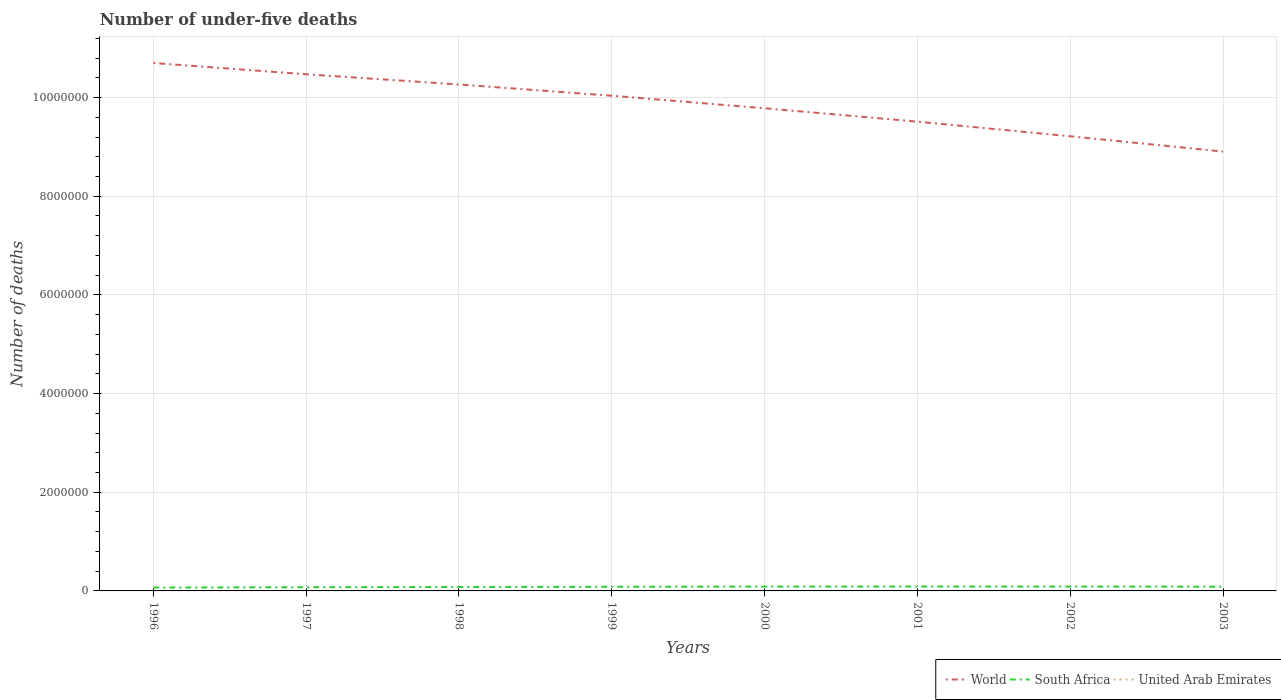Across all years, what is the maximum number of under-five deaths in South Africa?
Offer a terse response. 6.91e+04. In which year was the number of under-five deaths in United Arab Emirates maximum?
Keep it short and to the point. 2003. What is the total number of under-five deaths in South Africa in the graph?
Your answer should be compact. -2.02e+04. What is the difference between the highest and the second highest number of under-five deaths in World?
Keep it short and to the point. 1.80e+06. What is the difference between the highest and the lowest number of under-five deaths in United Arab Emirates?
Provide a succinct answer. 5. Is the number of under-five deaths in World strictly greater than the number of under-five deaths in South Africa over the years?
Offer a terse response. No. How many years are there in the graph?
Offer a terse response. 8. What is the difference between two consecutive major ticks on the Y-axis?
Provide a succinct answer. 2.00e+06. Where does the legend appear in the graph?
Offer a terse response. Bottom right. What is the title of the graph?
Provide a succinct answer. Number of under-five deaths. What is the label or title of the X-axis?
Your response must be concise. Years. What is the label or title of the Y-axis?
Offer a very short reply. Number of deaths. What is the Number of deaths of World in 1996?
Your answer should be compact. 1.07e+07. What is the Number of deaths in South Africa in 1996?
Make the answer very short. 6.91e+04. What is the Number of deaths in United Arab Emirates in 1996?
Provide a succinct answer. 561. What is the Number of deaths in World in 1997?
Provide a succinct answer. 1.05e+07. What is the Number of deaths in South Africa in 1997?
Your answer should be very brief. 7.42e+04. What is the Number of deaths of United Arab Emirates in 1997?
Your answer should be very brief. 557. What is the Number of deaths of World in 1998?
Your response must be concise. 1.03e+07. What is the Number of deaths in South Africa in 1998?
Ensure brevity in your answer.  7.96e+04. What is the Number of deaths of United Arab Emirates in 1998?
Give a very brief answer. 557. What is the Number of deaths in World in 1999?
Offer a terse response. 1.00e+07. What is the Number of deaths of South Africa in 1999?
Provide a succinct answer. 8.43e+04. What is the Number of deaths in United Arab Emirates in 1999?
Offer a very short reply. 563. What is the Number of deaths of World in 2000?
Your answer should be compact. 9.78e+06. What is the Number of deaths in South Africa in 2000?
Your response must be concise. 8.79e+04. What is the Number of deaths of United Arab Emirates in 2000?
Offer a very short reply. 563. What is the Number of deaths in World in 2001?
Your answer should be very brief. 9.51e+06. What is the Number of deaths of South Africa in 2001?
Your response must be concise. 8.93e+04. What is the Number of deaths in United Arab Emirates in 2001?
Provide a short and direct response. 544. What is the Number of deaths of World in 2002?
Your response must be concise. 9.21e+06. What is the Number of deaths of South Africa in 2002?
Provide a succinct answer. 8.84e+04. What is the Number of deaths of United Arab Emirates in 2002?
Ensure brevity in your answer.  523. What is the Number of deaths in World in 2003?
Your response must be concise. 8.91e+06. What is the Number of deaths in South Africa in 2003?
Your response must be concise. 8.58e+04. What is the Number of deaths in United Arab Emirates in 2003?
Your answer should be compact. 514. Across all years, what is the maximum Number of deaths of World?
Offer a terse response. 1.07e+07. Across all years, what is the maximum Number of deaths of South Africa?
Your response must be concise. 8.93e+04. Across all years, what is the maximum Number of deaths of United Arab Emirates?
Make the answer very short. 563. Across all years, what is the minimum Number of deaths of World?
Offer a very short reply. 8.91e+06. Across all years, what is the minimum Number of deaths in South Africa?
Offer a terse response. 6.91e+04. Across all years, what is the minimum Number of deaths in United Arab Emirates?
Ensure brevity in your answer.  514. What is the total Number of deaths in World in the graph?
Provide a succinct answer. 7.89e+07. What is the total Number of deaths in South Africa in the graph?
Your response must be concise. 6.59e+05. What is the total Number of deaths in United Arab Emirates in the graph?
Your answer should be very brief. 4382. What is the difference between the Number of deaths in World in 1996 and that in 1997?
Give a very brief answer. 2.29e+05. What is the difference between the Number of deaths of South Africa in 1996 and that in 1997?
Keep it short and to the point. -5126. What is the difference between the Number of deaths of World in 1996 and that in 1998?
Your answer should be very brief. 4.36e+05. What is the difference between the Number of deaths in South Africa in 1996 and that in 1998?
Offer a terse response. -1.05e+04. What is the difference between the Number of deaths in United Arab Emirates in 1996 and that in 1998?
Make the answer very short. 4. What is the difference between the Number of deaths of World in 1996 and that in 1999?
Ensure brevity in your answer.  6.64e+05. What is the difference between the Number of deaths of South Africa in 1996 and that in 1999?
Ensure brevity in your answer.  -1.52e+04. What is the difference between the Number of deaths of United Arab Emirates in 1996 and that in 1999?
Ensure brevity in your answer.  -2. What is the difference between the Number of deaths in World in 1996 and that in 2000?
Offer a very short reply. 9.18e+05. What is the difference between the Number of deaths of South Africa in 1996 and that in 2000?
Your answer should be very brief. -1.88e+04. What is the difference between the Number of deaths in World in 1996 and that in 2001?
Provide a short and direct response. 1.19e+06. What is the difference between the Number of deaths in South Africa in 1996 and that in 2001?
Provide a short and direct response. -2.02e+04. What is the difference between the Number of deaths of World in 1996 and that in 2002?
Your response must be concise. 1.49e+06. What is the difference between the Number of deaths in South Africa in 1996 and that in 2002?
Make the answer very short. -1.93e+04. What is the difference between the Number of deaths of United Arab Emirates in 1996 and that in 2002?
Your answer should be very brief. 38. What is the difference between the Number of deaths in World in 1996 and that in 2003?
Your response must be concise. 1.80e+06. What is the difference between the Number of deaths of South Africa in 1996 and that in 2003?
Your response must be concise. -1.67e+04. What is the difference between the Number of deaths in United Arab Emirates in 1996 and that in 2003?
Your answer should be very brief. 47. What is the difference between the Number of deaths of World in 1997 and that in 1998?
Offer a terse response. 2.07e+05. What is the difference between the Number of deaths of South Africa in 1997 and that in 1998?
Make the answer very short. -5402. What is the difference between the Number of deaths in United Arab Emirates in 1997 and that in 1998?
Your answer should be very brief. 0. What is the difference between the Number of deaths of World in 1997 and that in 1999?
Your answer should be very brief. 4.35e+05. What is the difference between the Number of deaths of South Africa in 1997 and that in 1999?
Provide a short and direct response. -1.01e+04. What is the difference between the Number of deaths of World in 1997 and that in 2000?
Your answer should be compact. 6.89e+05. What is the difference between the Number of deaths of South Africa in 1997 and that in 2000?
Your response must be concise. -1.37e+04. What is the difference between the Number of deaths in World in 1997 and that in 2001?
Your answer should be compact. 9.60e+05. What is the difference between the Number of deaths in South Africa in 1997 and that in 2001?
Keep it short and to the point. -1.51e+04. What is the difference between the Number of deaths in World in 1997 and that in 2002?
Offer a terse response. 1.26e+06. What is the difference between the Number of deaths of South Africa in 1997 and that in 2002?
Offer a terse response. -1.42e+04. What is the difference between the Number of deaths of World in 1997 and that in 2003?
Offer a terse response. 1.57e+06. What is the difference between the Number of deaths in South Africa in 1997 and that in 2003?
Offer a very short reply. -1.15e+04. What is the difference between the Number of deaths of World in 1998 and that in 1999?
Your answer should be compact. 2.28e+05. What is the difference between the Number of deaths in South Africa in 1998 and that in 1999?
Provide a short and direct response. -4712. What is the difference between the Number of deaths in United Arab Emirates in 1998 and that in 1999?
Offer a terse response. -6. What is the difference between the Number of deaths of World in 1998 and that in 2000?
Ensure brevity in your answer.  4.82e+05. What is the difference between the Number of deaths in South Africa in 1998 and that in 2000?
Your answer should be very brief. -8266. What is the difference between the Number of deaths in World in 1998 and that in 2001?
Provide a short and direct response. 7.53e+05. What is the difference between the Number of deaths in South Africa in 1998 and that in 2001?
Give a very brief answer. -9711. What is the difference between the Number of deaths of World in 1998 and that in 2002?
Offer a very short reply. 1.05e+06. What is the difference between the Number of deaths of South Africa in 1998 and that in 2002?
Offer a very short reply. -8818. What is the difference between the Number of deaths in World in 1998 and that in 2003?
Offer a very short reply. 1.36e+06. What is the difference between the Number of deaths of South Africa in 1998 and that in 2003?
Your answer should be very brief. -6147. What is the difference between the Number of deaths in United Arab Emirates in 1998 and that in 2003?
Make the answer very short. 43. What is the difference between the Number of deaths of World in 1999 and that in 2000?
Keep it short and to the point. 2.54e+05. What is the difference between the Number of deaths in South Africa in 1999 and that in 2000?
Keep it short and to the point. -3554. What is the difference between the Number of deaths in World in 1999 and that in 2001?
Offer a very short reply. 5.25e+05. What is the difference between the Number of deaths in South Africa in 1999 and that in 2001?
Provide a succinct answer. -4999. What is the difference between the Number of deaths in United Arab Emirates in 1999 and that in 2001?
Your response must be concise. 19. What is the difference between the Number of deaths in World in 1999 and that in 2002?
Your answer should be compact. 8.22e+05. What is the difference between the Number of deaths in South Africa in 1999 and that in 2002?
Your response must be concise. -4106. What is the difference between the Number of deaths in World in 1999 and that in 2003?
Your answer should be very brief. 1.13e+06. What is the difference between the Number of deaths of South Africa in 1999 and that in 2003?
Offer a very short reply. -1435. What is the difference between the Number of deaths in World in 2000 and that in 2001?
Your answer should be compact. 2.71e+05. What is the difference between the Number of deaths of South Africa in 2000 and that in 2001?
Provide a short and direct response. -1445. What is the difference between the Number of deaths in World in 2000 and that in 2002?
Give a very brief answer. 5.68e+05. What is the difference between the Number of deaths of South Africa in 2000 and that in 2002?
Give a very brief answer. -552. What is the difference between the Number of deaths of United Arab Emirates in 2000 and that in 2002?
Provide a succinct answer. 40. What is the difference between the Number of deaths in World in 2000 and that in 2003?
Give a very brief answer. 8.78e+05. What is the difference between the Number of deaths in South Africa in 2000 and that in 2003?
Your answer should be very brief. 2119. What is the difference between the Number of deaths of United Arab Emirates in 2000 and that in 2003?
Your answer should be compact. 49. What is the difference between the Number of deaths of World in 2001 and that in 2002?
Offer a terse response. 2.97e+05. What is the difference between the Number of deaths in South Africa in 2001 and that in 2002?
Offer a very short reply. 893. What is the difference between the Number of deaths of World in 2001 and that in 2003?
Offer a terse response. 6.07e+05. What is the difference between the Number of deaths in South Africa in 2001 and that in 2003?
Provide a short and direct response. 3564. What is the difference between the Number of deaths of United Arab Emirates in 2001 and that in 2003?
Your answer should be very brief. 30. What is the difference between the Number of deaths in World in 2002 and that in 2003?
Offer a very short reply. 3.10e+05. What is the difference between the Number of deaths in South Africa in 2002 and that in 2003?
Make the answer very short. 2671. What is the difference between the Number of deaths in World in 1996 and the Number of deaths in South Africa in 1997?
Provide a short and direct response. 1.06e+07. What is the difference between the Number of deaths of World in 1996 and the Number of deaths of United Arab Emirates in 1997?
Provide a succinct answer. 1.07e+07. What is the difference between the Number of deaths of South Africa in 1996 and the Number of deaths of United Arab Emirates in 1997?
Your answer should be compact. 6.85e+04. What is the difference between the Number of deaths in World in 1996 and the Number of deaths in South Africa in 1998?
Offer a very short reply. 1.06e+07. What is the difference between the Number of deaths in World in 1996 and the Number of deaths in United Arab Emirates in 1998?
Provide a succinct answer. 1.07e+07. What is the difference between the Number of deaths of South Africa in 1996 and the Number of deaths of United Arab Emirates in 1998?
Keep it short and to the point. 6.85e+04. What is the difference between the Number of deaths in World in 1996 and the Number of deaths in South Africa in 1999?
Give a very brief answer. 1.06e+07. What is the difference between the Number of deaths in World in 1996 and the Number of deaths in United Arab Emirates in 1999?
Your response must be concise. 1.07e+07. What is the difference between the Number of deaths in South Africa in 1996 and the Number of deaths in United Arab Emirates in 1999?
Your answer should be very brief. 6.85e+04. What is the difference between the Number of deaths in World in 1996 and the Number of deaths in South Africa in 2000?
Offer a very short reply. 1.06e+07. What is the difference between the Number of deaths of World in 1996 and the Number of deaths of United Arab Emirates in 2000?
Give a very brief answer. 1.07e+07. What is the difference between the Number of deaths in South Africa in 1996 and the Number of deaths in United Arab Emirates in 2000?
Ensure brevity in your answer.  6.85e+04. What is the difference between the Number of deaths in World in 1996 and the Number of deaths in South Africa in 2001?
Keep it short and to the point. 1.06e+07. What is the difference between the Number of deaths in World in 1996 and the Number of deaths in United Arab Emirates in 2001?
Keep it short and to the point. 1.07e+07. What is the difference between the Number of deaths in South Africa in 1996 and the Number of deaths in United Arab Emirates in 2001?
Offer a very short reply. 6.85e+04. What is the difference between the Number of deaths of World in 1996 and the Number of deaths of South Africa in 2002?
Make the answer very short. 1.06e+07. What is the difference between the Number of deaths in World in 1996 and the Number of deaths in United Arab Emirates in 2002?
Your response must be concise. 1.07e+07. What is the difference between the Number of deaths in South Africa in 1996 and the Number of deaths in United Arab Emirates in 2002?
Make the answer very short. 6.86e+04. What is the difference between the Number of deaths in World in 1996 and the Number of deaths in South Africa in 2003?
Provide a short and direct response. 1.06e+07. What is the difference between the Number of deaths of World in 1996 and the Number of deaths of United Arab Emirates in 2003?
Provide a short and direct response. 1.07e+07. What is the difference between the Number of deaths in South Africa in 1996 and the Number of deaths in United Arab Emirates in 2003?
Your answer should be compact. 6.86e+04. What is the difference between the Number of deaths in World in 1997 and the Number of deaths in South Africa in 1998?
Your answer should be very brief. 1.04e+07. What is the difference between the Number of deaths of World in 1997 and the Number of deaths of United Arab Emirates in 1998?
Offer a very short reply. 1.05e+07. What is the difference between the Number of deaths in South Africa in 1997 and the Number of deaths in United Arab Emirates in 1998?
Offer a very short reply. 7.37e+04. What is the difference between the Number of deaths in World in 1997 and the Number of deaths in South Africa in 1999?
Provide a short and direct response. 1.04e+07. What is the difference between the Number of deaths of World in 1997 and the Number of deaths of United Arab Emirates in 1999?
Make the answer very short. 1.05e+07. What is the difference between the Number of deaths in South Africa in 1997 and the Number of deaths in United Arab Emirates in 1999?
Your answer should be compact. 7.36e+04. What is the difference between the Number of deaths in World in 1997 and the Number of deaths in South Africa in 2000?
Give a very brief answer. 1.04e+07. What is the difference between the Number of deaths in World in 1997 and the Number of deaths in United Arab Emirates in 2000?
Your answer should be very brief. 1.05e+07. What is the difference between the Number of deaths of South Africa in 1997 and the Number of deaths of United Arab Emirates in 2000?
Your answer should be very brief. 7.36e+04. What is the difference between the Number of deaths in World in 1997 and the Number of deaths in South Africa in 2001?
Make the answer very short. 1.04e+07. What is the difference between the Number of deaths of World in 1997 and the Number of deaths of United Arab Emirates in 2001?
Keep it short and to the point. 1.05e+07. What is the difference between the Number of deaths of South Africa in 1997 and the Number of deaths of United Arab Emirates in 2001?
Your answer should be compact. 7.37e+04. What is the difference between the Number of deaths of World in 1997 and the Number of deaths of South Africa in 2002?
Ensure brevity in your answer.  1.04e+07. What is the difference between the Number of deaths of World in 1997 and the Number of deaths of United Arab Emirates in 2002?
Make the answer very short. 1.05e+07. What is the difference between the Number of deaths in South Africa in 1997 and the Number of deaths in United Arab Emirates in 2002?
Your answer should be compact. 7.37e+04. What is the difference between the Number of deaths in World in 1997 and the Number of deaths in South Africa in 2003?
Make the answer very short. 1.04e+07. What is the difference between the Number of deaths of World in 1997 and the Number of deaths of United Arab Emirates in 2003?
Give a very brief answer. 1.05e+07. What is the difference between the Number of deaths of South Africa in 1997 and the Number of deaths of United Arab Emirates in 2003?
Make the answer very short. 7.37e+04. What is the difference between the Number of deaths of World in 1998 and the Number of deaths of South Africa in 1999?
Make the answer very short. 1.02e+07. What is the difference between the Number of deaths in World in 1998 and the Number of deaths in United Arab Emirates in 1999?
Give a very brief answer. 1.03e+07. What is the difference between the Number of deaths of South Africa in 1998 and the Number of deaths of United Arab Emirates in 1999?
Provide a short and direct response. 7.90e+04. What is the difference between the Number of deaths in World in 1998 and the Number of deaths in South Africa in 2000?
Provide a succinct answer. 1.02e+07. What is the difference between the Number of deaths in World in 1998 and the Number of deaths in United Arab Emirates in 2000?
Provide a succinct answer. 1.03e+07. What is the difference between the Number of deaths in South Africa in 1998 and the Number of deaths in United Arab Emirates in 2000?
Provide a short and direct response. 7.90e+04. What is the difference between the Number of deaths of World in 1998 and the Number of deaths of South Africa in 2001?
Give a very brief answer. 1.02e+07. What is the difference between the Number of deaths in World in 1998 and the Number of deaths in United Arab Emirates in 2001?
Your answer should be very brief. 1.03e+07. What is the difference between the Number of deaths in South Africa in 1998 and the Number of deaths in United Arab Emirates in 2001?
Your response must be concise. 7.91e+04. What is the difference between the Number of deaths of World in 1998 and the Number of deaths of South Africa in 2002?
Offer a terse response. 1.02e+07. What is the difference between the Number of deaths in World in 1998 and the Number of deaths in United Arab Emirates in 2002?
Offer a terse response. 1.03e+07. What is the difference between the Number of deaths of South Africa in 1998 and the Number of deaths of United Arab Emirates in 2002?
Ensure brevity in your answer.  7.91e+04. What is the difference between the Number of deaths of World in 1998 and the Number of deaths of South Africa in 2003?
Offer a very short reply. 1.02e+07. What is the difference between the Number of deaths of World in 1998 and the Number of deaths of United Arab Emirates in 2003?
Offer a terse response. 1.03e+07. What is the difference between the Number of deaths of South Africa in 1998 and the Number of deaths of United Arab Emirates in 2003?
Make the answer very short. 7.91e+04. What is the difference between the Number of deaths in World in 1999 and the Number of deaths in South Africa in 2000?
Keep it short and to the point. 9.95e+06. What is the difference between the Number of deaths in World in 1999 and the Number of deaths in United Arab Emirates in 2000?
Offer a terse response. 1.00e+07. What is the difference between the Number of deaths of South Africa in 1999 and the Number of deaths of United Arab Emirates in 2000?
Make the answer very short. 8.38e+04. What is the difference between the Number of deaths in World in 1999 and the Number of deaths in South Africa in 2001?
Provide a succinct answer. 9.95e+06. What is the difference between the Number of deaths of World in 1999 and the Number of deaths of United Arab Emirates in 2001?
Your answer should be compact. 1.00e+07. What is the difference between the Number of deaths in South Africa in 1999 and the Number of deaths in United Arab Emirates in 2001?
Offer a terse response. 8.38e+04. What is the difference between the Number of deaths of World in 1999 and the Number of deaths of South Africa in 2002?
Offer a very short reply. 9.95e+06. What is the difference between the Number of deaths in World in 1999 and the Number of deaths in United Arab Emirates in 2002?
Offer a terse response. 1.00e+07. What is the difference between the Number of deaths in South Africa in 1999 and the Number of deaths in United Arab Emirates in 2002?
Your answer should be compact. 8.38e+04. What is the difference between the Number of deaths of World in 1999 and the Number of deaths of South Africa in 2003?
Your answer should be compact. 9.95e+06. What is the difference between the Number of deaths in World in 1999 and the Number of deaths in United Arab Emirates in 2003?
Give a very brief answer. 1.00e+07. What is the difference between the Number of deaths in South Africa in 1999 and the Number of deaths in United Arab Emirates in 2003?
Your response must be concise. 8.38e+04. What is the difference between the Number of deaths of World in 2000 and the Number of deaths of South Africa in 2001?
Provide a succinct answer. 9.69e+06. What is the difference between the Number of deaths in World in 2000 and the Number of deaths in United Arab Emirates in 2001?
Provide a short and direct response. 9.78e+06. What is the difference between the Number of deaths in South Africa in 2000 and the Number of deaths in United Arab Emirates in 2001?
Provide a short and direct response. 8.73e+04. What is the difference between the Number of deaths of World in 2000 and the Number of deaths of South Africa in 2002?
Your response must be concise. 9.69e+06. What is the difference between the Number of deaths in World in 2000 and the Number of deaths in United Arab Emirates in 2002?
Provide a short and direct response. 9.78e+06. What is the difference between the Number of deaths in South Africa in 2000 and the Number of deaths in United Arab Emirates in 2002?
Ensure brevity in your answer.  8.74e+04. What is the difference between the Number of deaths in World in 2000 and the Number of deaths in South Africa in 2003?
Your response must be concise. 9.70e+06. What is the difference between the Number of deaths of World in 2000 and the Number of deaths of United Arab Emirates in 2003?
Offer a terse response. 9.78e+06. What is the difference between the Number of deaths in South Africa in 2000 and the Number of deaths in United Arab Emirates in 2003?
Your response must be concise. 8.74e+04. What is the difference between the Number of deaths of World in 2001 and the Number of deaths of South Africa in 2002?
Ensure brevity in your answer.  9.42e+06. What is the difference between the Number of deaths of World in 2001 and the Number of deaths of United Arab Emirates in 2002?
Make the answer very short. 9.51e+06. What is the difference between the Number of deaths in South Africa in 2001 and the Number of deaths in United Arab Emirates in 2002?
Provide a short and direct response. 8.88e+04. What is the difference between the Number of deaths in World in 2001 and the Number of deaths in South Africa in 2003?
Offer a very short reply. 9.43e+06. What is the difference between the Number of deaths in World in 2001 and the Number of deaths in United Arab Emirates in 2003?
Ensure brevity in your answer.  9.51e+06. What is the difference between the Number of deaths of South Africa in 2001 and the Number of deaths of United Arab Emirates in 2003?
Provide a succinct answer. 8.88e+04. What is the difference between the Number of deaths in World in 2002 and the Number of deaths in South Africa in 2003?
Your answer should be very brief. 9.13e+06. What is the difference between the Number of deaths in World in 2002 and the Number of deaths in United Arab Emirates in 2003?
Keep it short and to the point. 9.21e+06. What is the difference between the Number of deaths in South Africa in 2002 and the Number of deaths in United Arab Emirates in 2003?
Keep it short and to the point. 8.79e+04. What is the average Number of deaths in World per year?
Your response must be concise. 9.86e+06. What is the average Number of deaths in South Africa per year?
Provide a succinct answer. 8.23e+04. What is the average Number of deaths of United Arab Emirates per year?
Make the answer very short. 547.75. In the year 1996, what is the difference between the Number of deaths in World and Number of deaths in South Africa?
Ensure brevity in your answer.  1.06e+07. In the year 1996, what is the difference between the Number of deaths of World and Number of deaths of United Arab Emirates?
Keep it short and to the point. 1.07e+07. In the year 1996, what is the difference between the Number of deaths in South Africa and Number of deaths in United Arab Emirates?
Offer a terse response. 6.85e+04. In the year 1997, what is the difference between the Number of deaths of World and Number of deaths of South Africa?
Your answer should be very brief. 1.04e+07. In the year 1997, what is the difference between the Number of deaths in World and Number of deaths in United Arab Emirates?
Ensure brevity in your answer.  1.05e+07. In the year 1997, what is the difference between the Number of deaths of South Africa and Number of deaths of United Arab Emirates?
Provide a succinct answer. 7.37e+04. In the year 1998, what is the difference between the Number of deaths in World and Number of deaths in South Africa?
Give a very brief answer. 1.02e+07. In the year 1998, what is the difference between the Number of deaths of World and Number of deaths of United Arab Emirates?
Provide a succinct answer. 1.03e+07. In the year 1998, what is the difference between the Number of deaths in South Africa and Number of deaths in United Arab Emirates?
Keep it short and to the point. 7.91e+04. In the year 1999, what is the difference between the Number of deaths in World and Number of deaths in South Africa?
Ensure brevity in your answer.  9.95e+06. In the year 1999, what is the difference between the Number of deaths in World and Number of deaths in United Arab Emirates?
Provide a short and direct response. 1.00e+07. In the year 1999, what is the difference between the Number of deaths of South Africa and Number of deaths of United Arab Emirates?
Provide a short and direct response. 8.38e+04. In the year 2000, what is the difference between the Number of deaths in World and Number of deaths in South Africa?
Your answer should be very brief. 9.69e+06. In the year 2000, what is the difference between the Number of deaths in World and Number of deaths in United Arab Emirates?
Your answer should be compact. 9.78e+06. In the year 2000, what is the difference between the Number of deaths of South Africa and Number of deaths of United Arab Emirates?
Offer a terse response. 8.73e+04. In the year 2001, what is the difference between the Number of deaths of World and Number of deaths of South Africa?
Provide a short and direct response. 9.42e+06. In the year 2001, what is the difference between the Number of deaths of World and Number of deaths of United Arab Emirates?
Provide a succinct answer. 9.51e+06. In the year 2001, what is the difference between the Number of deaths in South Africa and Number of deaths in United Arab Emirates?
Make the answer very short. 8.88e+04. In the year 2002, what is the difference between the Number of deaths of World and Number of deaths of South Africa?
Your answer should be very brief. 9.13e+06. In the year 2002, what is the difference between the Number of deaths in World and Number of deaths in United Arab Emirates?
Offer a terse response. 9.21e+06. In the year 2002, what is the difference between the Number of deaths in South Africa and Number of deaths in United Arab Emirates?
Keep it short and to the point. 8.79e+04. In the year 2003, what is the difference between the Number of deaths of World and Number of deaths of South Africa?
Provide a short and direct response. 8.82e+06. In the year 2003, what is the difference between the Number of deaths in World and Number of deaths in United Arab Emirates?
Provide a short and direct response. 8.90e+06. In the year 2003, what is the difference between the Number of deaths of South Africa and Number of deaths of United Arab Emirates?
Provide a short and direct response. 8.52e+04. What is the ratio of the Number of deaths of World in 1996 to that in 1997?
Give a very brief answer. 1.02. What is the ratio of the Number of deaths of South Africa in 1996 to that in 1997?
Give a very brief answer. 0.93. What is the ratio of the Number of deaths of United Arab Emirates in 1996 to that in 1997?
Your response must be concise. 1.01. What is the ratio of the Number of deaths of World in 1996 to that in 1998?
Your answer should be compact. 1.04. What is the ratio of the Number of deaths of South Africa in 1996 to that in 1998?
Provide a short and direct response. 0.87. What is the ratio of the Number of deaths of World in 1996 to that in 1999?
Keep it short and to the point. 1.07. What is the ratio of the Number of deaths of South Africa in 1996 to that in 1999?
Your response must be concise. 0.82. What is the ratio of the Number of deaths of United Arab Emirates in 1996 to that in 1999?
Offer a very short reply. 1. What is the ratio of the Number of deaths in World in 1996 to that in 2000?
Offer a very short reply. 1.09. What is the ratio of the Number of deaths in South Africa in 1996 to that in 2000?
Make the answer very short. 0.79. What is the ratio of the Number of deaths in United Arab Emirates in 1996 to that in 2000?
Your response must be concise. 1. What is the ratio of the Number of deaths of World in 1996 to that in 2001?
Your response must be concise. 1.12. What is the ratio of the Number of deaths in South Africa in 1996 to that in 2001?
Your answer should be very brief. 0.77. What is the ratio of the Number of deaths of United Arab Emirates in 1996 to that in 2001?
Provide a succinct answer. 1.03. What is the ratio of the Number of deaths in World in 1996 to that in 2002?
Offer a terse response. 1.16. What is the ratio of the Number of deaths of South Africa in 1996 to that in 2002?
Ensure brevity in your answer.  0.78. What is the ratio of the Number of deaths in United Arab Emirates in 1996 to that in 2002?
Make the answer very short. 1.07. What is the ratio of the Number of deaths in World in 1996 to that in 2003?
Offer a terse response. 1.2. What is the ratio of the Number of deaths in South Africa in 1996 to that in 2003?
Provide a succinct answer. 0.81. What is the ratio of the Number of deaths in United Arab Emirates in 1996 to that in 2003?
Your response must be concise. 1.09. What is the ratio of the Number of deaths in World in 1997 to that in 1998?
Keep it short and to the point. 1.02. What is the ratio of the Number of deaths of South Africa in 1997 to that in 1998?
Your response must be concise. 0.93. What is the ratio of the Number of deaths in United Arab Emirates in 1997 to that in 1998?
Your response must be concise. 1. What is the ratio of the Number of deaths in World in 1997 to that in 1999?
Offer a terse response. 1.04. What is the ratio of the Number of deaths in South Africa in 1997 to that in 1999?
Ensure brevity in your answer.  0.88. What is the ratio of the Number of deaths in United Arab Emirates in 1997 to that in 1999?
Offer a terse response. 0.99. What is the ratio of the Number of deaths of World in 1997 to that in 2000?
Offer a very short reply. 1.07. What is the ratio of the Number of deaths of South Africa in 1997 to that in 2000?
Make the answer very short. 0.84. What is the ratio of the Number of deaths of United Arab Emirates in 1997 to that in 2000?
Offer a very short reply. 0.99. What is the ratio of the Number of deaths in World in 1997 to that in 2001?
Offer a terse response. 1.1. What is the ratio of the Number of deaths of South Africa in 1997 to that in 2001?
Your answer should be compact. 0.83. What is the ratio of the Number of deaths of United Arab Emirates in 1997 to that in 2001?
Keep it short and to the point. 1.02. What is the ratio of the Number of deaths in World in 1997 to that in 2002?
Your answer should be very brief. 1.14. What is the ratio of the Number of deaths of South Africa in 1997 to that in 2002?
Offer a very short reply. 0.84. What is the ratio of the Number of deaths of United Arab Emirates in 1997 to that in 2002?
Keep it short and to the point. 1.06. What is the ratio of the Number of deaths of World in 1997 to that in 2003?
Offer a terse response. 1.18. What is the ratio of the Number of deaths of South Africa in 1997 to that in 2003?
Offer a very short reply. 0.87. What is the ratio of the Number of deaths of United Arab Emirates in 1997 to that in 2003?
Your answer should be very brief. 1.08. What is the ratio of the Number of deaths in World in 1998 to that in 1999?
Your response must be concise. 1.02. What is the ratio of the Number of deaths in South Africa in 1998 to that in 1999?
Your response must be concise. 0.94. What is the ratio of the Number of deaths in United Arab Emirates in 1998 to that in 1999?
Make the answer very short. 0.99. What is the ratio of the Number of deaths of World in 1998 to that in 2000?
Your answer should be compact. 1.05. What is the ratio of the Number of deaths in South Africa in 1998 to that in 2000?
Your answer should be very brief. 0.91. What is the ratio of the Number of deaths in United Arab Emirates in 1998 to that in 2000?
Keep it short and to the point. 0.99. What is the ratio of the Number of deaths in World in 1998 to that in 2001?
Offer a very short reply. 1.08. What is the ratio of the Number of deaths of South Africa in 1998 to that in 2001?
Your answer should be very brief. 0.89. What is the ratio of the Number of deaths of United Arab Emirates in 1998 to that in 2001?
Give a very brief answer. 1.02. What is the ratio of the Number of deaths in World in 1998 to that in 2002?
Make the answer very short. 1.11. What is the ratio of the Number of deaths in South Africa in 1998 to that in 2002?
Keep it short and to the point. 0.9. What is the ratio of the Number of deaths in United Arab Emirates in 1998 to that in 2002?
Make the answer very short. 1.06. What is the ratio of the Number of deaths in World in 1998 to that in 2003?
Provide a succinct answer. 1.15. What is the ratio of the Number of deaths of South Africa in 1998 to that in 2003?
Provide a short and direct response. 0.93. What is the ratio of the Number of deaths in United Arab Emirates in 1998 to that in 2003?
Provide a short and direct response. 1.08. What is the ratio of the Number of deaths in South Africa in 1999 to that in 2000?
Provide a short and direct response. 0.96. What is the ratio of the Number of deaths of United Arab Emirates in 1999 to that in 2000?
Give a very brief answer. 1. What is the ratio of the Number of deaths of World in 1999 to that in 2001?
Provide a succinct answer. 1.06. What is the ratio of the Number of deaths in South Africa in 1999 to that in 2001?
Ensure brevity in your answer.  0.94. What is the ratio of the Number of deaths in United Arab Emirates in 1999 to that in 2001?
Offer a very short reply. 1.03. What is the ratio of the Number of deaths in World in 1999 to that in 2002?
Offer a terse response. 1.09. What is the ratio of the Number of deaths in South Africa in 1999 to that in 2002?
Your answer should be very brief. 0.95. What is the ratio of the Number of deaths of United Arab Emirates in 1999 to that in 2002?
Make the answer very short. 1.08. What is the ratio of the Number of deaths in World in 1999 to that in 2003?
Keep it short and to the point. 1.13. What is the ratio of the Number of deaths of South Africa in 1999 to that in 2003?
Your response must be concise. 0.98. What is the ratio of the Number of deaths in United Arab Emirates in 1999 to that in 2003?
Provide a succinct answer. 1.1. What is the ratio of the Number of deaths of World in 2000 to that in 2001?
Provide a succinct answer. 1.03. What is the ratio of the Number of deaths of South Africa in 2000 to that in 2001?
Provide a short and direct response. 0.98. What is the ratio of the Number of deaths of United Arab Emirates in 2000 to that in 2001?
Your answer should be compact. 1.03. What is the ratio of the Number of deaths of World in 2000 to that in 2002?
Give a very brief answer. 1.06. What is the ratio of the Number of deaths of United Arab Emirates in 2000 to that in 2002?
Offer a very short reply. 1.08. What is the ratio of the Number of deaths of World in 2000 to that in 2003?
Give a very brief answer. 1.1. What is the ratio of the Number of deaths in South Africa in 2000 to that in 2003?
Provide a succinct answer. 1.02. What is the ratio of the Number of deaths in United Arab Emirates in 2000 to that in 2003?
Your response must be concise. 1.1. What is the ratio of the Number of deaths of World in 2001 to that in 2002?
Offer a very short reply. 1.03. What is the ratio of the Number of deaths of South Africa in 2001 to that in 2002?
Ensure brevity in your answer.  1.01. What is the ratio of the Number of deaths in United Arab Emirates in 2001 to that in 2002?
Make the answer very short. 1.04. What is the ratio of the Number of deaths of World in 2001 to that in 2003?
Ensure brevity in your answer.  1.07. What is the ratio of the Number of deaths in South Africa in 2001 to that in 2003?
Provide a short and direct response. 1.04. What is the ratio of the Number of deaths of United Arab Emirates in 2001 to that in 2003?
Make the answer very short. 1.06. What is the ratio of the Number of deaths in World in 2002 to that in 2003?
Your answer should be compact. 1.03. What is the ratio of the Number of deaths of South Africa in 2002 to that in 2003?
Your answer should be compact. 1.03. What is the ratio of the Number of deaths in United Arab Emirates in 2002 to that in 2003?
Your answer should be compact. 1.02. What is the difference between the highest and the second highest Number of deaths in World?
Offer a very short reply. 2.29e+05. What is the difference between the highest and the second highest Number of deaths in South Africa?
Offer a very short reply. 893. What is the difference between the highest and the second highest Number of deaths of United Arab Emirates?
Make the answer very short. 0. What is the difference between the highest and the lowest Number of deaths in World?
Your response must be concise. 1.80e+06. What is the difference between the highest and the lowest Number of deaths of South Africa?
Make the answer very short. 2.02e+04. 